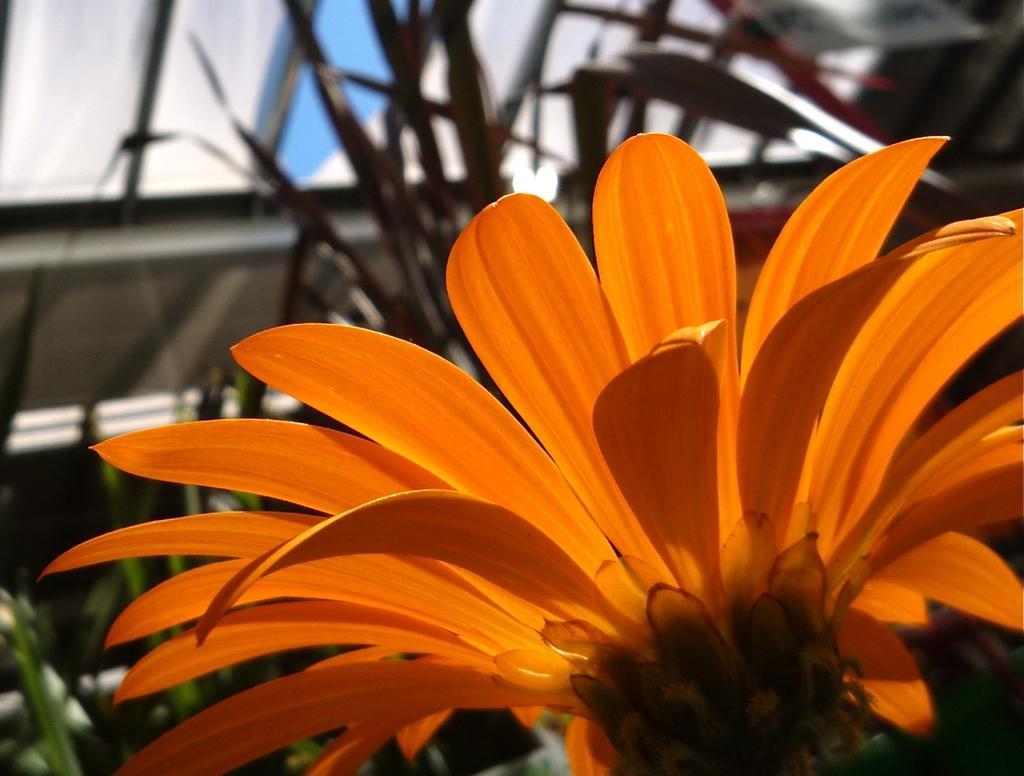Could you give a brief overview of what you see in this image? In this image we can see an orange color flower. In the background we can see grass and an object. 